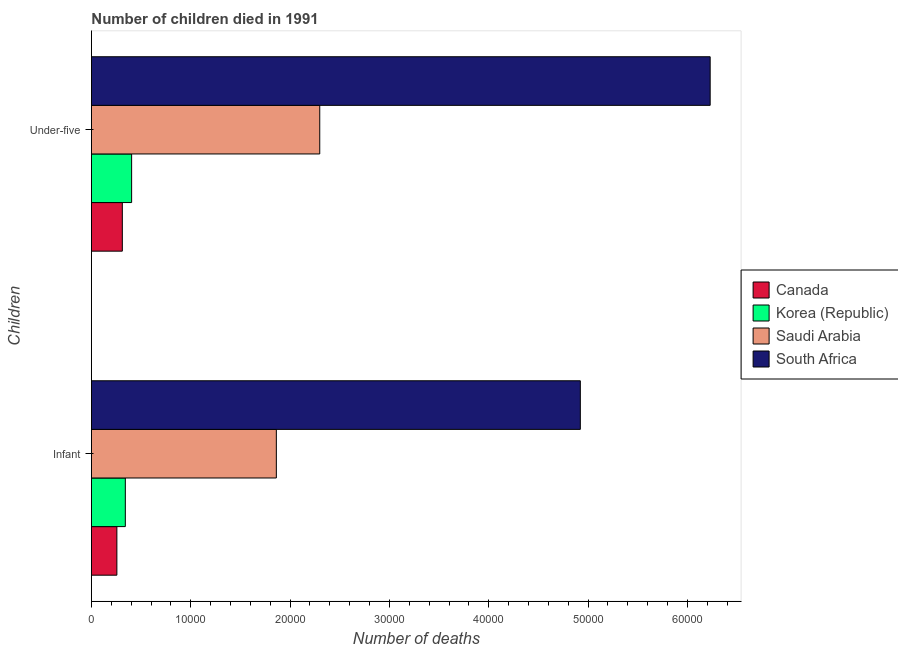How many different coloured bars are there?
Ensure brevity in your answer.  4. What is the label of the 2nd group of bars from the top?
Offer a very short reply. Infant. What is the number of infant deaths in Canada?
Give a very brief answer. 2563. Across all countries, what is the maximum number of under-five deaths?
Ensure brevity in your answer.  6.23e+04. Across all countries, what is the minimum number of infant deaths?
Your answer should be very brief. 2563. In which country was the number of infant deaths maximum?
Offer a terse response. South Africa. What is the total number of under-five deaths in the graph?
Your answer should be very brief. 9.24e+04. What is the difference between the number of under-five deaths in Saudi Arabia and that in Korea (Republic)?
Ensure brevity in your answer.  1.89e+04. What is the difference between the number of under-five deaths in South Africa and the number of infant deaths in Saudi Arabia?
Provide a succinct answer. 4.37e+04. What is the average number of under-five deaths per country?
Offer a terse response. 2.31e+04. What is the difference between the number of infant deaths and number of under-five deaths in Korea (Republic)?
Provide a succinct answer. -633. What is the ratio of the number of under-five deaths in South Africa to that in Korea (Republic)?
Ensure brevity in your answer.  15.39. Is the number of under-five deaths in South Africa less than that in Canada?
Make the answer very short. No. What does the 4th bar from the bottom in Infant represents?
Your answer should be compact. South Africa. Are all the bars in the graph horizontal?
Your answer should be very brief. Yes. Are the values on the major ticks of X-axis written in scientific E-notation?
Offer a very short reply. No. Does the graph contain grids?
Make the answer very short. No. Where does the legend appear in the graph?
Keep it short and to the point. Center right. How many legend labels are there?
Your answer should be very brief. 4. What is the title of the graph?
Give a very brief answer. Number of children died in 1991. Does "Haiti" appear as one of the legend labels in the graph?
Keep it short and to the point. No. What is the label or title of the X-axis?
Give a very brief answer. Number of deaths. What is the label or title of the Y-axis?
Offer a terse response. Children. What is the Number of deaths of Canada in Infant?
Your answer should be very brief. 2563. What is the Number of deaths of Korea (Republic) in Infant?
Provide a short and direct response. 3414. What is the Number of deaths in Saudi Arabia in Infant?
Offer a very short reply. 1.86e+04. What is the Number of deaths in South Africa in Infant?
Provide a short and direct response. 4.92e+04. What is the Number of deaths in Canada in Under-five?
Your response must be concise. 3111. What is the Number of deaths of Korea (Republic) in Under-five?
Ensure brevity in your answer.  4047. What is the Number of deaths of Saudi Arabia in Under-five?
Your answer should be very brief. 2.30e+04. What is the Number of deaths in South Africa in Under-five?
Provide a short and direct response. 6.23e+04. Across all Children, what is the maximum Number of deaths of Canada?
Make the answer very short. 3111. Across all Children, what is the maximum Number of deaths of Korea (Republic)?
Your answer should be very brief. 4047. Across all Children, what is the maximum Number of deaths in Saudi Arabia?
Your answer should be compact. 2.30e+04. Across all Children, what is the maximum Number of deaths in South Africa?
Give a very brief answer. 6.23e+04. Across all Children, what is the minimum Number of deaths in Canada?
Offer a terse response. 2563. Across all Children, what is the minimum Number of deaths of Korea (Republic)?
Your answer should be compact. 3414. Across all Children, what is the minimum Number of deaths of Saudi Arabia?
Your answer should be compact. 1.86e+04. Across all Children, what is the minimum Number of deaths of South Africa?
Offer a very short reply. 4.92e+04. What is the total Number of deaths of Canada in the graph?
Give a very brief answer. 5674. What is the total Number of deaths in Korea (Republic) in the graph?
Your answer should be very brief. 7461. What is the total Number of deaths in Saudi Arabia in the graph?
Make the answer very short. 4.16e+04. What is the total Number of deaths of South Africa in the graph?
Your answer should be very brief. 1.12e+05. What is the difference between the Number of deaths of Canada in Infant and that in Under-five?
Provide a short and direct response. -548. What is the difference between the Number of deaths in Korea (Republic) in Infant and that in Under-five?
Offer a very short reply. -633. What is the difference between the Number of deaths in Saudi Arabia in Infant and that in Under-five?
Keep it short and to the point. -4369. What is the difference between the Number of deaths in South Africa in Infant and that in Under-five?
Offer a very short reply. -1.31e+04. What is the difference between the Number of deaths of Canada in Infant and the Number of deaths of Korea (Republic) in Under-five?
Keep it short and to the point. -1484. What is the difference between the Number of deaths of Canada in Infant and the Number of deaths of Saudi Arabia in Under-five?
Make the answer very short. -2.04e+04. What is the difference between the Number of deaths in Canada in Infant and the Number of deaths in South Africa in Under-five?
Offer a terse response. -5.97e+04. What is the difference between the Number of deaths in Korea (Republic) in Infant and the Number of deaths in Saudi Arabia in Under-five?
Keep it short and to the point. -1.96e+04. What is the difference between the Number of deaths of Korea (Republic) in Infant and the Number of deaths of South Africa in Under-five?
Your answer should be compact. -5.89e+04. What is the difference between the Number of deaths of Saudi Arabia in Infant and the Number of deaths of South Africa in Under-five?
Give a very brief answer. -4.37e+04. What is the average Number of deaths of Canada per Children?
Keep it short and to the point. 2837. What is the average Number of deaths in Korea (Republic) per Children?
Your answer should be compact. 3730.5. What is the average Number of deaths of Saudi Arabia per Children?
Your response must be concise. 2.08e+04. What is the average Number of deaths in South Africa per Children?
Your answer should be compact. 5.58e+04. What is the difference between the Number of deaths in Canada and Number of deaths in Korea (Republic) in Infant?
Provide a short and direct response. -851. What is the difference between the Number of deaths of Canada and Number of deaths of Saudi Arabia in Infant?
Give a very brief answer. -1.61e+04. What is the difference between the Number of deaths in Canada and Number of deaths in South Africa in Infant?
Your response must be concise. -4.67e+04. What is the difference between the Number of deaths of Korea (Republic) and Number of deaths of Saudi Arabia in Infant?
Give a very brief answer. -1.52e+04. What is the difference between the Number of deaths of Korea (Republic) and Number of deaths of South Africa in Infant?
Give a very brief answer. -4.58e+04. What is the difference between the Number of deaths of Saudi Arabia and Number of deaths of South Africa in Infant?
Your answer should be very brief. -3.06e+04. What is the difference between the Number of deaths of Canada and Number of deaths of Korea (Republic) in Under-five?
Provide a succinct answer. -936. What is the difference between the Number of deaths in Canada and Number of deaths in Saudi Arabia in Under-five?
Give a very brief answer. -1.99e+04. What is the difference between the Number of deaths in Canada and Number of deaths in South Africa in Under-five?
Ensure brevity in your answer.  -5.92e+04. What is the difference between the Number of deaths of Korea (Republic) and Number of deaths of Saudi Arabia in Under-five?
Offer a terse response. -1.89e+04. What is the difference between the Number of deaths in Korea (Republic) and Number of deaths in South Africa in Under-five?
Ensure brevity in your answer.  -5.82e+04. What is the difference between the Number of deaths of Saudi Arabia and Number of deaths of South Africa in Under-five?
Keep it short and to the point. -3.93e+04. What is the ratio of the Number of deaths in Canada in Infant to that in Under-five?
Give a very brief answer. 0.82. What is the ratio of the Number of deaths of Korea (Republic) in Infant to that in Under-five?
Provide a succinct answer. 0.84. What is the ratio of the Number of deaths of Saudi Arabia in Infant to that in Under-five?
Provide a short and direct response. 0.81. What is the ratio of the Number of deaths in South Africa in Infant to that in Under-five?
Make the answer very short. 0.79. What is the difference between the highest and the second highest Number of deaths in Canada?
Make the answer very short. 548. What is the difference between the highest and the second highest Number of deaths of Korea (Republic)?
Make the answer very short. 633. What is the difference between the highest and the second highest Number of deaths in Saudi Arabia?
Provide a succinct answer. 4369. What is the difference between the highest and the second highest Number of deaths in South Africa?
Make the answer very short. 1.31e+04. What is the difference between the highest and the lowest Number of deaths in Canada?
Provide a short and direct response. 548. What is the difference between the highest and the lowest Number of deaths in Korea (Republic)?
Keep it short and to the point. 633. What is the difference between the highest and the lowest Number of deaths of Saudi Arabia?
Your answer should be compact. 4369. What is the difference between the highest and the lowest Number of deaths of South Africa?
Provide a short and direct response. 1.31e+04. 